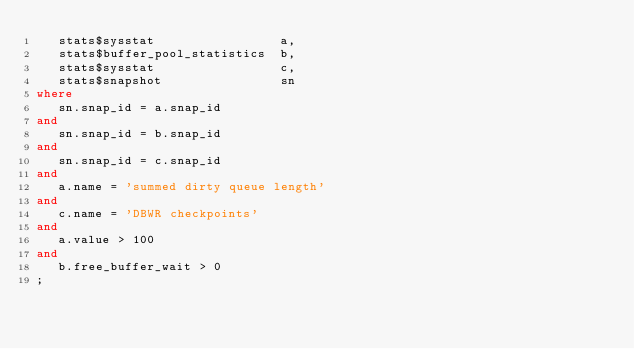<code> <loc_0><loc_0><loc_500><loc_500><_SQL_>   stats$sysstat                 a,
   stats$buffer_pool_statistics  b,
   stats$sysstat                 c,
   stats$snapshot                sn
where
   sn.snap_id = a.snap_id
and
   sn.snap_id = b.snap_id
and
   sn.snap_id = c.snap_id
and
   a.name = 'summed dirty queue length'
and
   c.name = 'DBWR checkpoints'
and
   a.value > 100
and
   b.free_buffer_wait > 0
;
</code> 